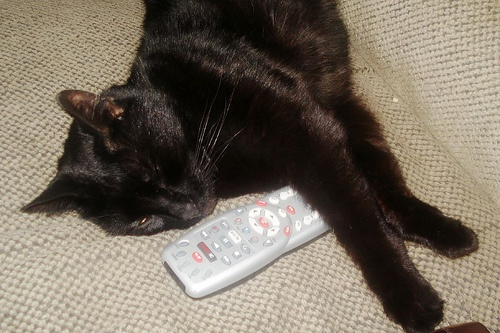Describe the objects in this image and their specific colors. I can see cat in gray, black, and maroon tones, couch in gray, tan, and lightgray tones, and remote in gray, lightgray, darkgray, and lightpink tones in this image. 